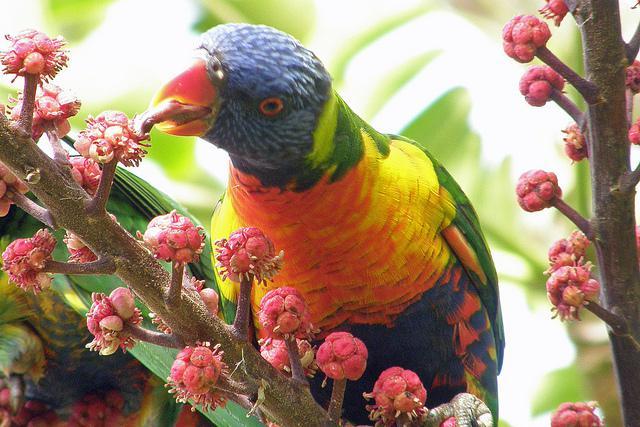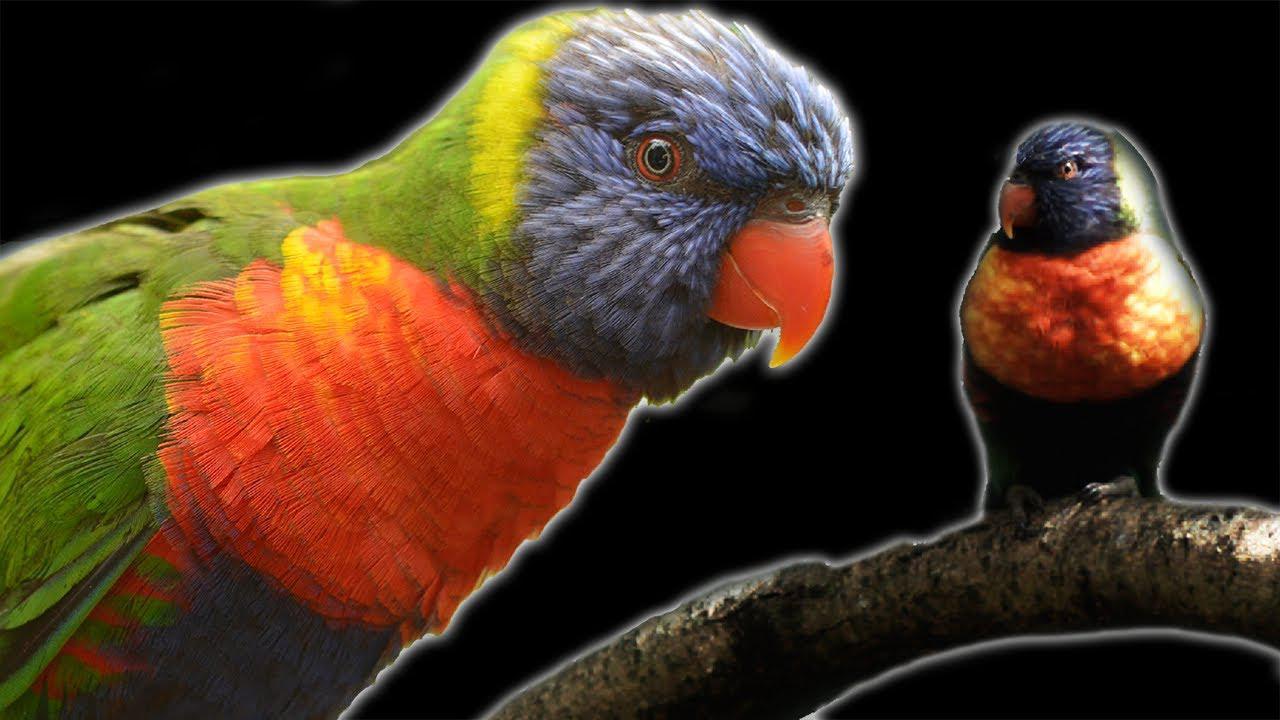The first image is the image on the left, the second image is the image on the right. Evaluate the accuracy of this statement regarding the images: "At least one image shows a colorful bird interacting with a human hand". Is it true? Answer yes or no. No. The first image is the image on the left, the second image is the image on the right. For the images shown, is this caption "There is at least two parrots in the right image." true? Answer yes or no. Yes. 